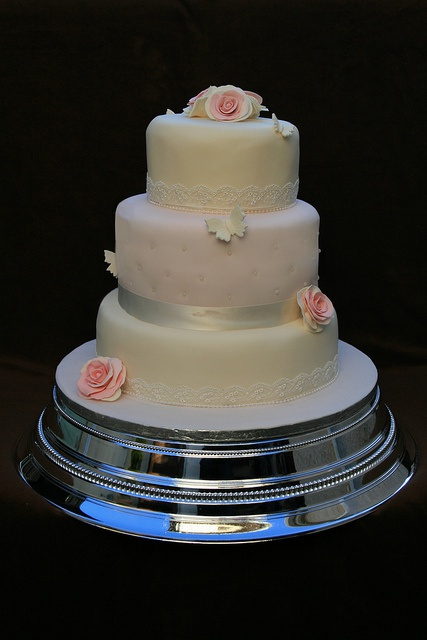Describe the objects in this image and their specific colors. I can see a cake in black, gray, and darkgray tones in this image. 